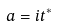<formula> <loc_0><loc_0><loc_500><loc_500>a = i t ^ { * }</formula> 